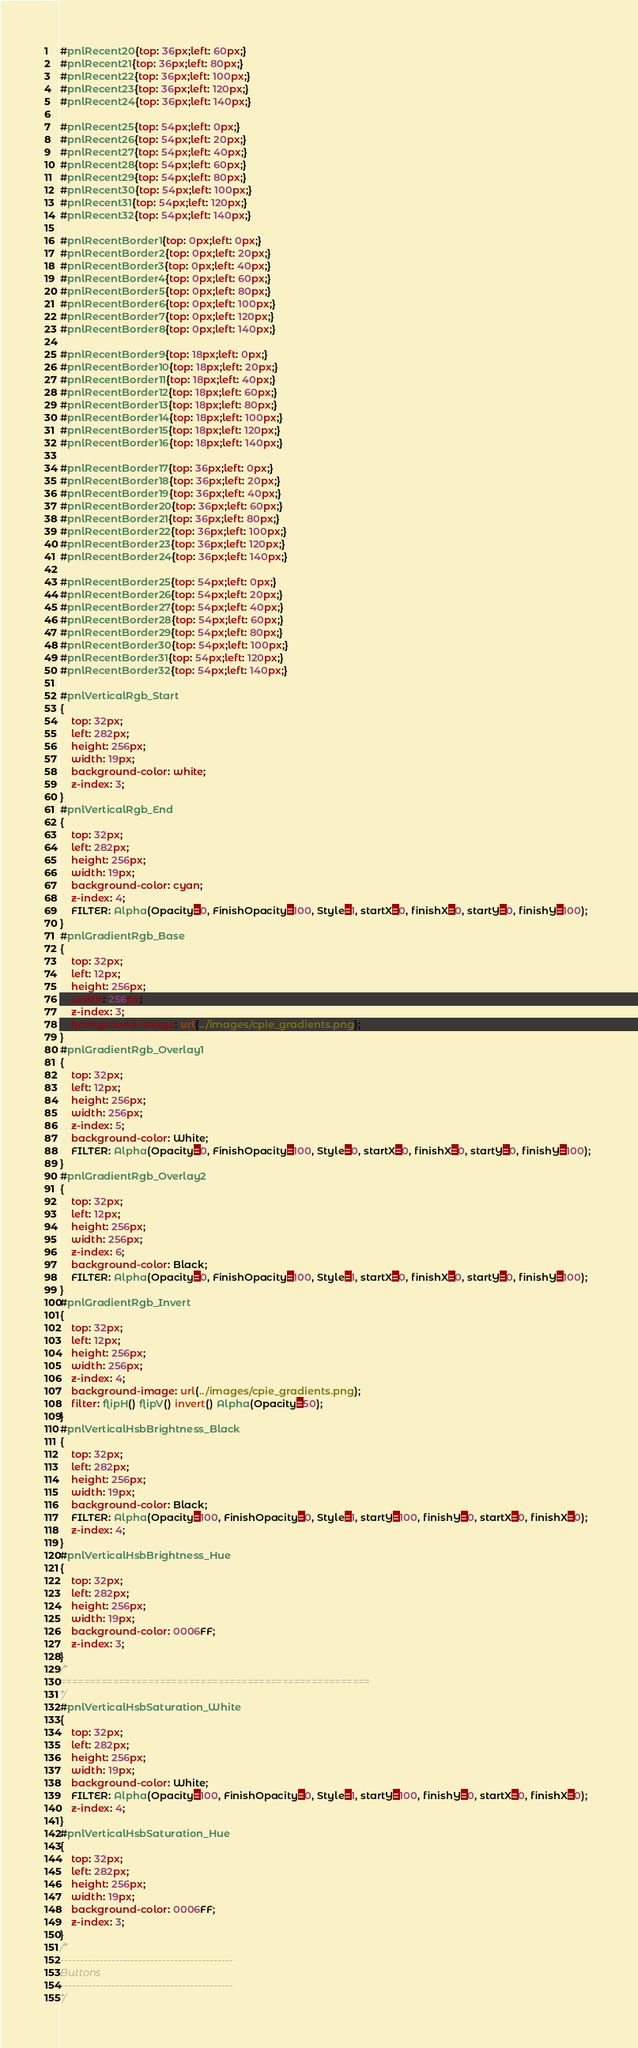Convert code to text. <code><loc_0><loc_0><loc_500><loc_500><_CSS_>#pnlRecent20{top: 36px;left: 60px;}
#pnlRecent21{top: 36px;left: 80px;}
#pnlRecent22{top: 36px;left: 100px;}
#pnlRecent23{top: 36px;left: 120px;}
#pnlRecent24{top: 36px;left: 140px;}

#pnlRecent25{top: 54px;left: 0px;}
#pnlRecent26{top: 54px;left: 20px;}
#pnlRecent27{top: 54px;left: 40px;}
#pnlRecent28{top: 54px;left: 60px;}
#pnlRecent29{top: 54px;left: 80px;}
#pnlRecent30{top: 54px;left: 100px;}
#pnlRecent31{top: 54px;left: 120px;}
#pnlRecent32{top: 54px;left: 140px;}

#pnlRecentBorder1{top: 0px;left: 0px;}
#pnlRecentBorder2{top: 0px;left: 20px;}
#pnlRecentBorder3{top: 0px;left: 40px;}
#pnlRecentBorder4{top: 0px;left: 60px;}
#pnlRecentBorder5{top: 0px;left: 80px;}
#pnlRecentBorder6{top: 0px;left: 100px;}
#pnlRecentBorder7{top: 0px;left: 120px;}
#pnlRecentBorder8{top: 0px;left: 140px;}

#pnlRecentBorder9{top: 18px;left: 0px;}
#pnlRecentBorder10{top: 18px;left: 20px;}
#pnlRecentBorder11{top: 18px;left: 40px;}
#pnlRecentBorder12{top: 18px;left: 60px;}
#pnlRecentBorder13{top: 18px;left: 80px;}
#pnlRecentBorder14{top: 18px;left: 100px;}
#pnlRecentBorder15{top: 18px;left: 120px;}
#pnlRecentBorder16{top: 18px;left: 140px;}

#pnlRecentBorder17{top: 36px;left: 0px;}
#pnlRecentBorder18{top: 36px;left: 20px;}
#pnlRecentBorder19{top: 36px;left: 40px;}
#pnlRecentBorder20{top: 36px;left: 60px;}
#pnlRecentBorder21{top: 36px;left: 80px;}
#pnlRecentBorder22{top: 36px;left: 100px;}
#pnlRecentBorder23{top: 36px;left: 120px;}
#pnlRecentBorder24{top: 36px;left: 140px;}

#pnlRecentBorder25{top: 54px;left: 0px;}
#pnlRecentBorder26{top: 54px;left: 20px;}
#pnlRecentBorder27{top: 54px;left: 40px;}
#pnlRecentBorder28{top: 54px;left: 60px;}
#pnlRecentBorder29{top: 54px;left: 80px;}
#pnlRecentBorder30{top: 54px;left: 100px;}
#pnlRecentBorder31{top: 54px;left: 120px;}
#pnlRecentBorder32{top: 54px;left: 140px;}

#pnlVerticalRgb_Start
{
	top: 32px;
	left: 282px;
	height: 256px;
	width: 19px;
	background-color: white;
	z-index: 3;
}
#pnlVerticalRgb_End
{
	top: 32px;
	left: 282px;
	height: 256px;
	width: 19px;
	background-color: cyan;
	z-index: 4;
	FILTER: Alpha(Opacity=0, FinishOpacity=100, Style=1, startX=0, finishX=0, startY=0, finishY=100); 
}
#pnlGradientRgb_Base
{
	top: 32px;
	left: 12px;
	height: 256px;
	width: 256px;
	z-index: 3;
	background-image: url(../images/cpie_gradients.png);
}
#pnlGradientRgb_Overlay1
{
	top: 32px;
	left: 12px;
	height: 256px;
	width: 256px;
	z-index: 5;
	background-color: White;
	FILTER: Alpha(Opacity=0, FinishOpacity=100, Style=0, startX=0, finishX=0, startY=0, finishY=100); 
}
#pnlGradientRgb_Overlay2
{
	top: 32px;
	left: 12px;
	height: 256px;
	width: 256px;
	z-index: 6;
	background-color: Black;
	FILTER: Alpha(Opacity=0, FinishOpacity=100, Style=1, startX=0, finishX=0, startY=0, finishY=100); 
}
#pnlGradientRgb_Invert
{
	top: 32px;
	left: 12px;
	height: 256px;
	width: 256px;
	z-index: 4;
	background-image: url(../images/cpie_gradients.png);
	filter: flipH() flipV() invert() Alpha(Opacity=50); 
}
#pnlVerticalHsbBrightness_Black
{
	top: 32px;
	left: 282px;
	height: 256px;
	width: 19px;
	background-color: Black;
	FILTER: Alpha(Opacity=100, FinishOpacity=0, Style=1, startY=100, finishY=0, startX=0, finishX=0); 
	z-index: 4;
}
#pnlVerticalHsbBrightness_Hue
{
	top: 32px;
	left: 282px;
	height: 256px;
	width: 19px;
	background-color: 0006FF;
	z-index: 3;
}
/*
=====================================================
*/
#pnlVerticalHsbSaturation_White
{
	top: 32px;
	left: 282px;
	height: 256px;
	width: 19px;
	background-color: White;
	FILTER: Alpha(Opacity=100, FinishOpacity=0, Style=1, startY=100, finishY=0, startX=0, finishX=0); 
	z-index: 4;
}
#pnlVerticalHsbSaturation_Hue
{
	top: 32px;
	left: 282px;
	height: 256px;
	width: 19px;
	background-color: 0006FF;
	z-index: 3;
}
/*
--------------------------------------------
Buttons
--------------------------------------------
*/</code> 